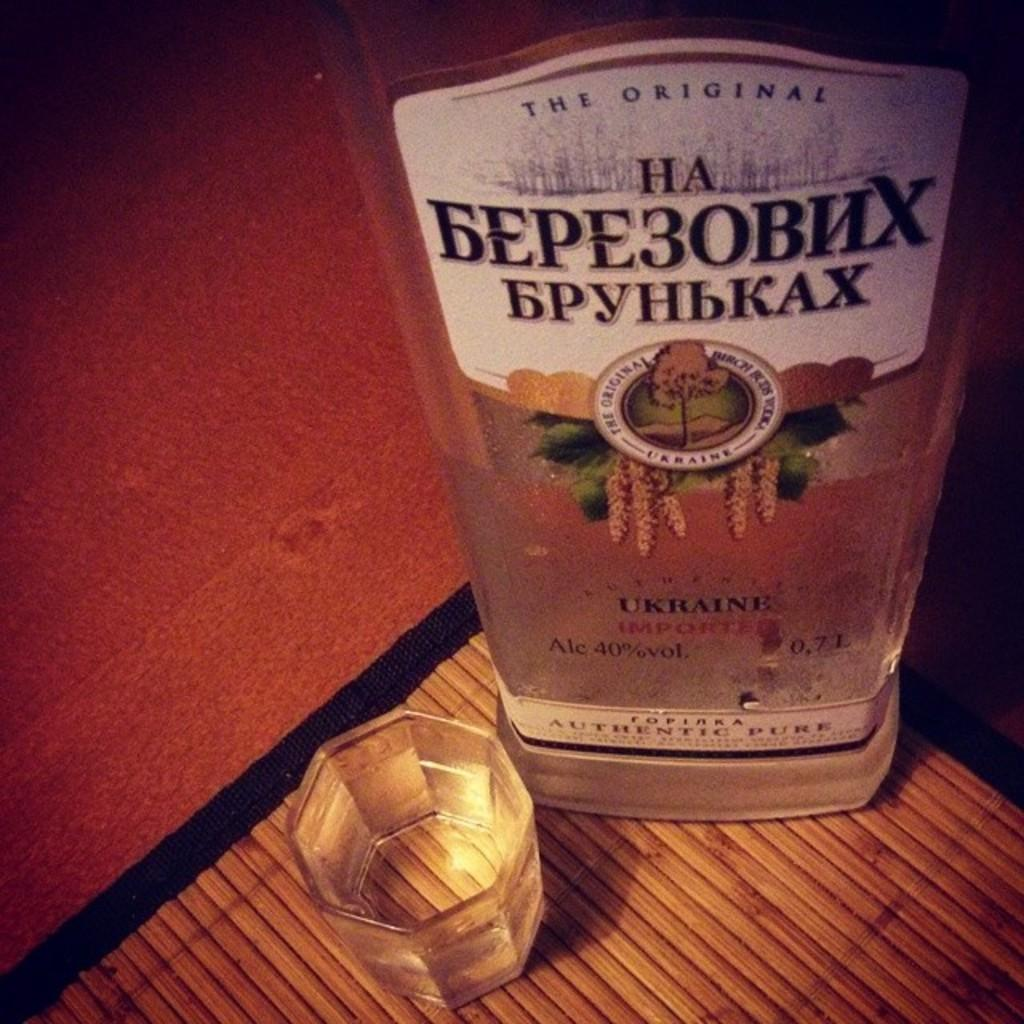<image>
Share a concise interpretation of the image provided. a bottle of the original ha ukraine alcohol 